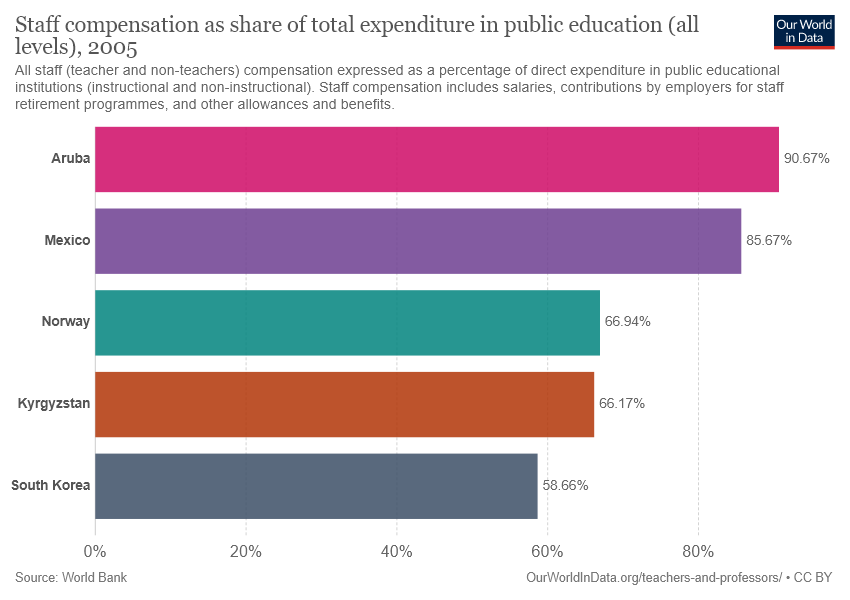Outline some significant characteristics in this image. The average of the bottom three countries is 63.92. The value of Mexico is 85.67. 